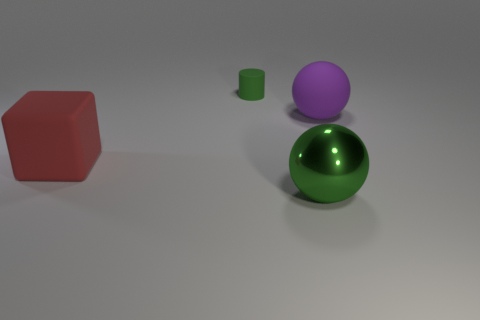Add 4 gray spheres. How many objects exist? 8 Subtract all blocks. How many objects are left? 3 Add 2 big brown metallic things. How many big brown metallic things exist? 2 Subtract 1 purple balls. How many objects are left? 3 Subtract all small gray rubber objects. Subtract all big purple rubber things. How many objects are left? 3 Add 4 big shiny things. How many big shiny things are left? 5 